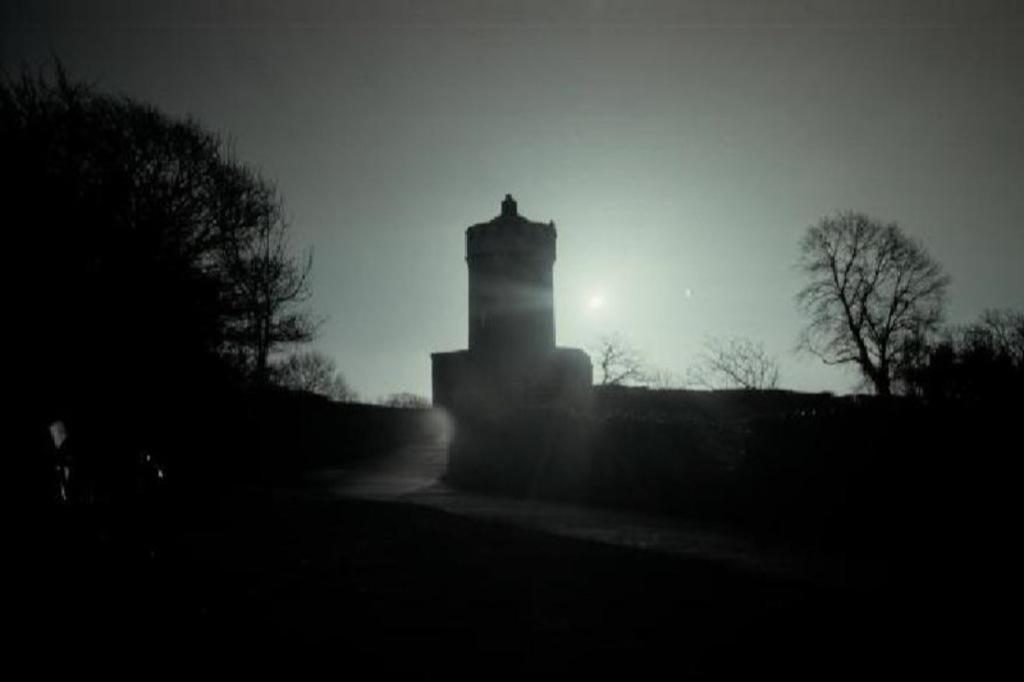Can you describe this image briefly? In the image we can see the black and white picture of the trees, construction, sky and the sun. 